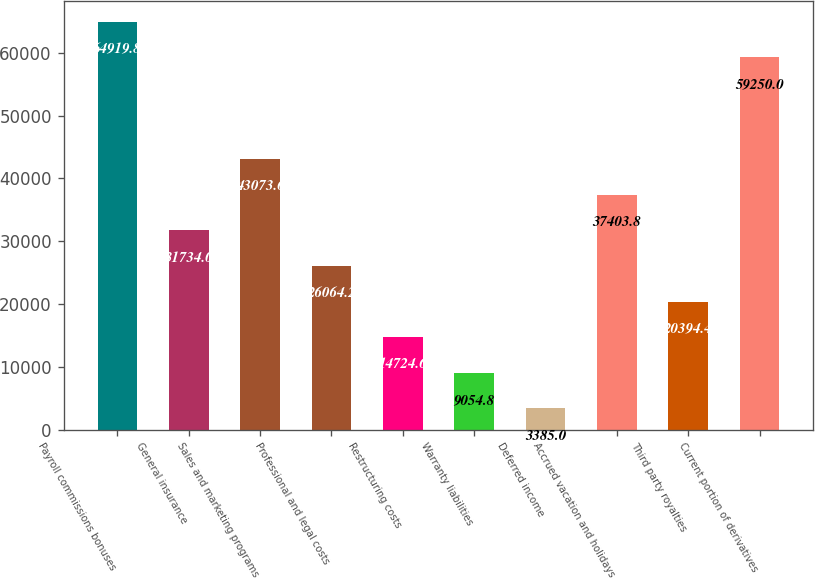Convert chart. <chart><loc_0><loc_0><loc_500><loc_500><bar_chart><fcel>Payroll commissions bonuses<fcel>General insurance<fcel>Sales and marketing programs<fcel>Professional and legal costs<fcel>Restructuring costs<fcel>Warranty liabilities<fcel>Deferred income<fcel>Accrued vacation and holidays<fcel>Third party royalties<fcel>Current portion of derivatives<nl><fcel>64919.8<fcel>31734<fcel>43073.6<fcel>26064.2<fcel>14724.6<fcel>9054.8<fcel>3385<fcel>37403.8<fcel>20394.4<fcel>59250<nl></chart> 